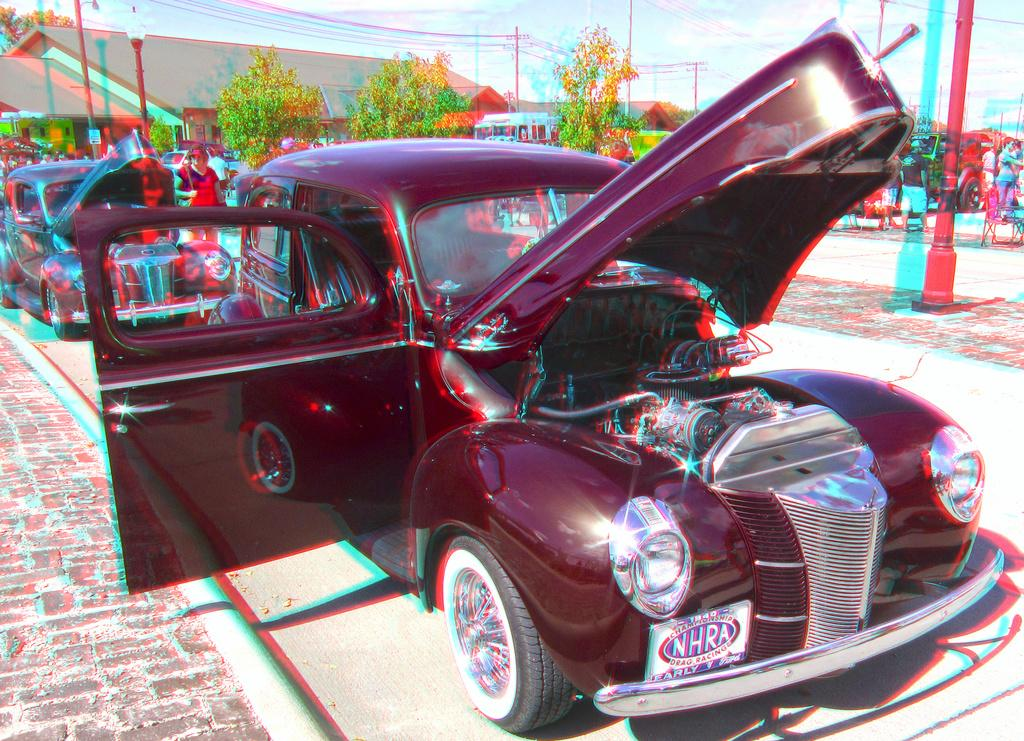How many cars are parked in the image? There are two cars parked in the image. What parts of one car are visible in the image? The door and bonnet of one car are visible in the image. What can be seen in the background of the image? There are trees in the background of the image. What objects are present in the image besides the cars? There is a pole and a light in the image. Can you see any corn growing near the cars in the image? There is no corn visible in the image; it features two parked cars, trees in the background, a pole, and a light. 